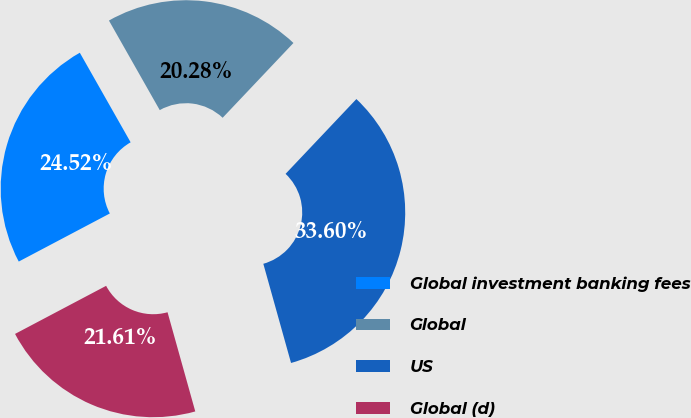Convert chart. <chart><loc_0><loc_0><loc_500><loc_500><pie_chart><fcel>Global investment banking fees<fcel>Global<fcel>US<fcel>Global (d)<nl><fcel>24.52%<fcel>20.28%<fcel>33.6%<fcel>21.61%<nl></chart> 